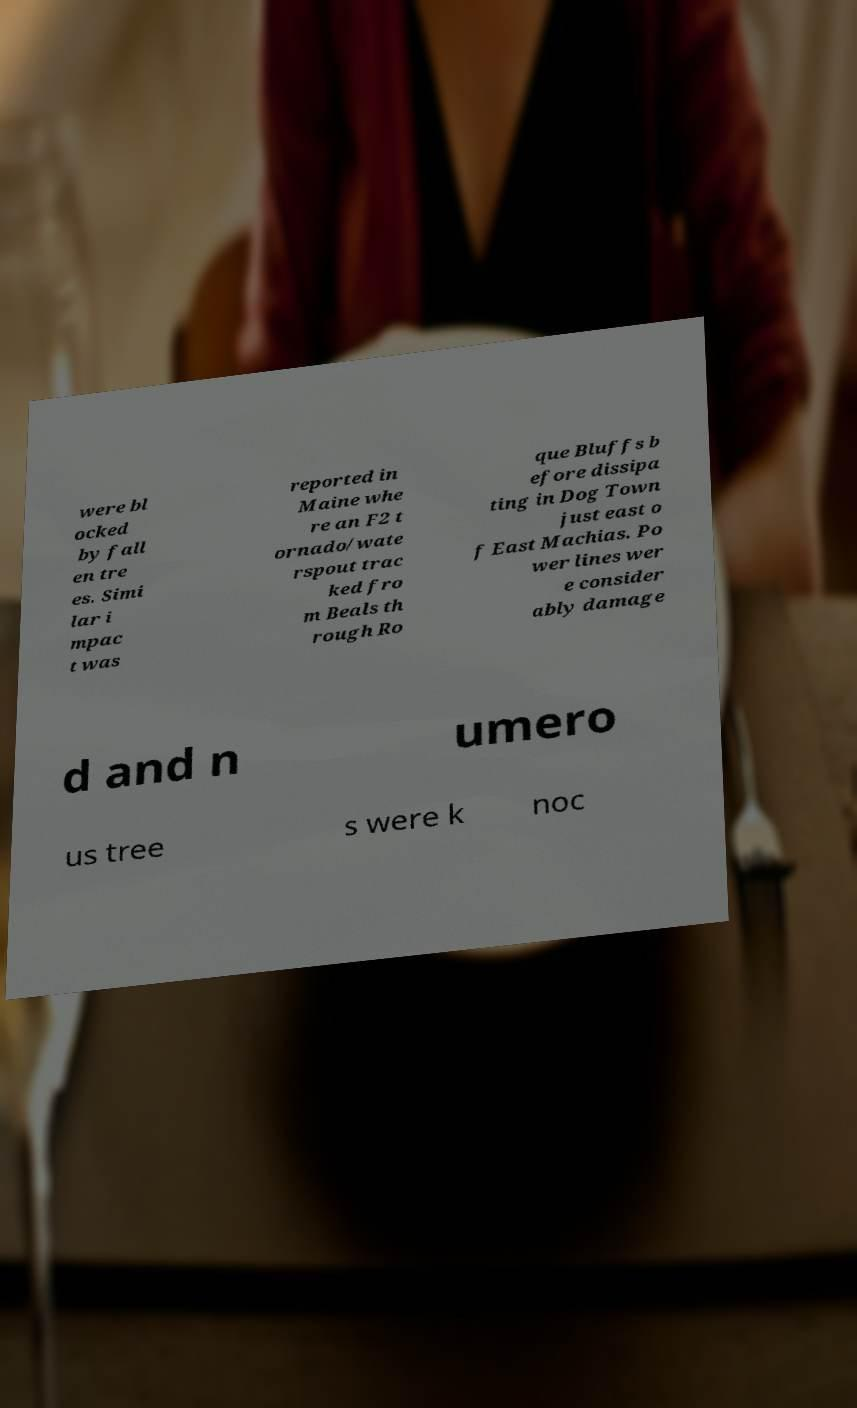Can you accurately transcribe the text from the provided image for me? were bl ocked by fall en tre es. Simi lar i mpac t was reported in Maine whe re an F2 t ornado/wate rspout trac ked fro m Beals th rough Ro que Bluffs b efore dissipa ting in Dog Town just east o f East Machias. Po wer lines wer e consider ably damage d and n umero us tree s were k noc 